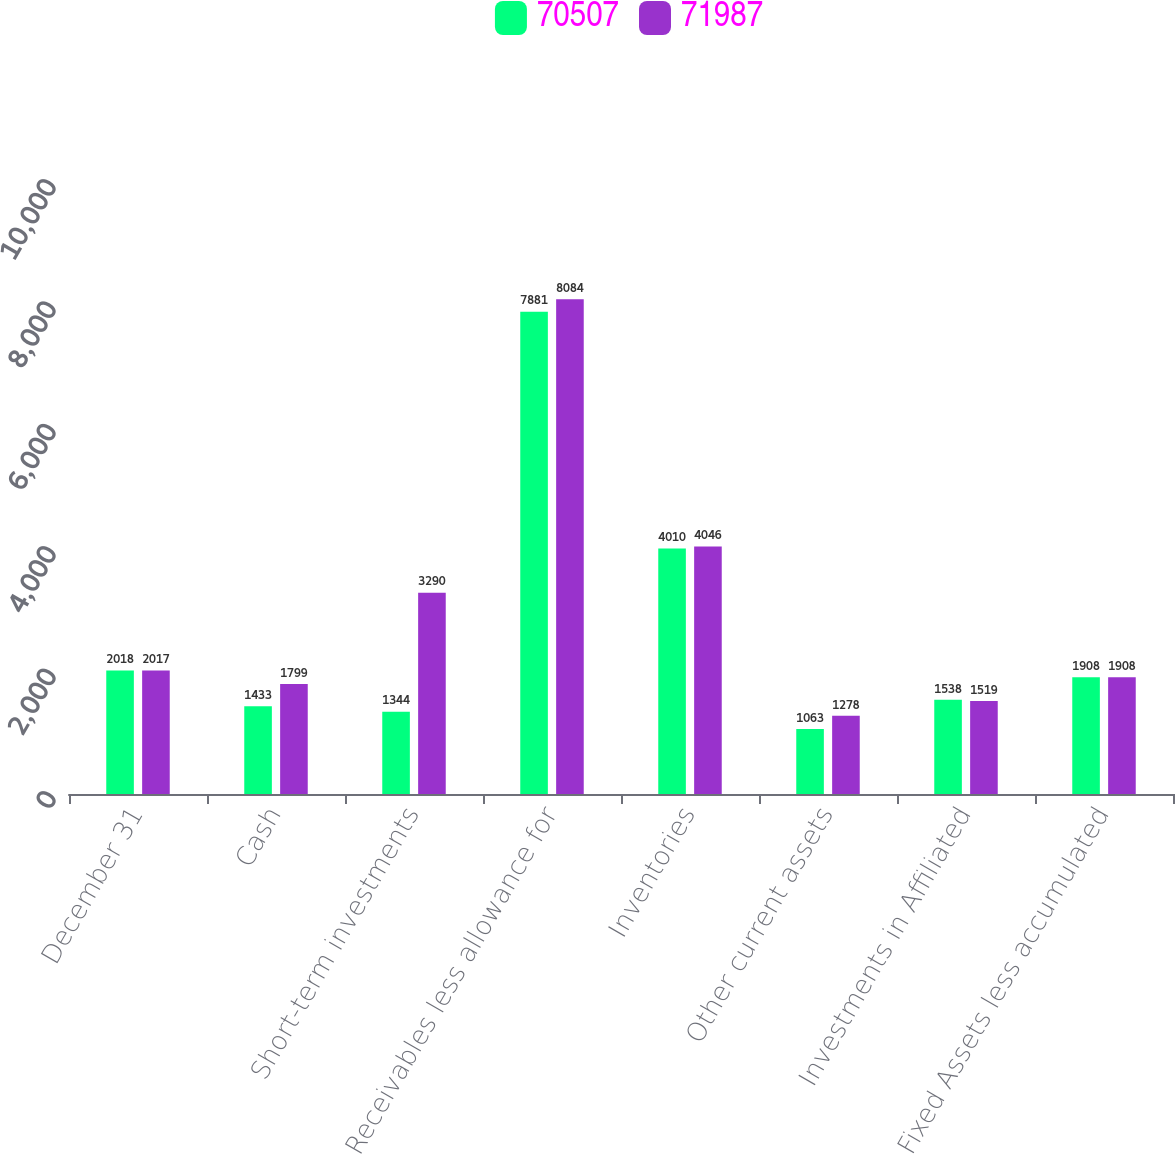Convert chart to OTSL. <chart><loc_0><loc_0><loc_500><loc_500><stacked_bar_chart><ecel><fcel>December 31<fcel>Cash<fcel>Short-term investments<fcel>Receivables less allowance for<fcel>Inventories<fcel>Other current assets<fcel>Investments in Affiliated<fcel>Fixed Assets less accumulated<nl><fcel>70507<fcel>2018<fcel>1433<fcel>1344<fcel>7881<fcel>4010<fcel>1063<fcel>1538<fcel>1908<nl><fcel>71987<fcel>2017<fcel>1799<fcel>3290<fcel>8084<fcel>4046<fcel>1278<fcel>1519<fcel>1908<nl></chart> 